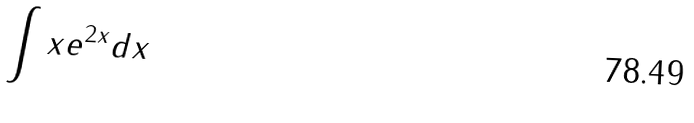<formula> <loc_0><loc_0><loc_500><loc_500>\int x e ^ { 2 x } d x</formula> 